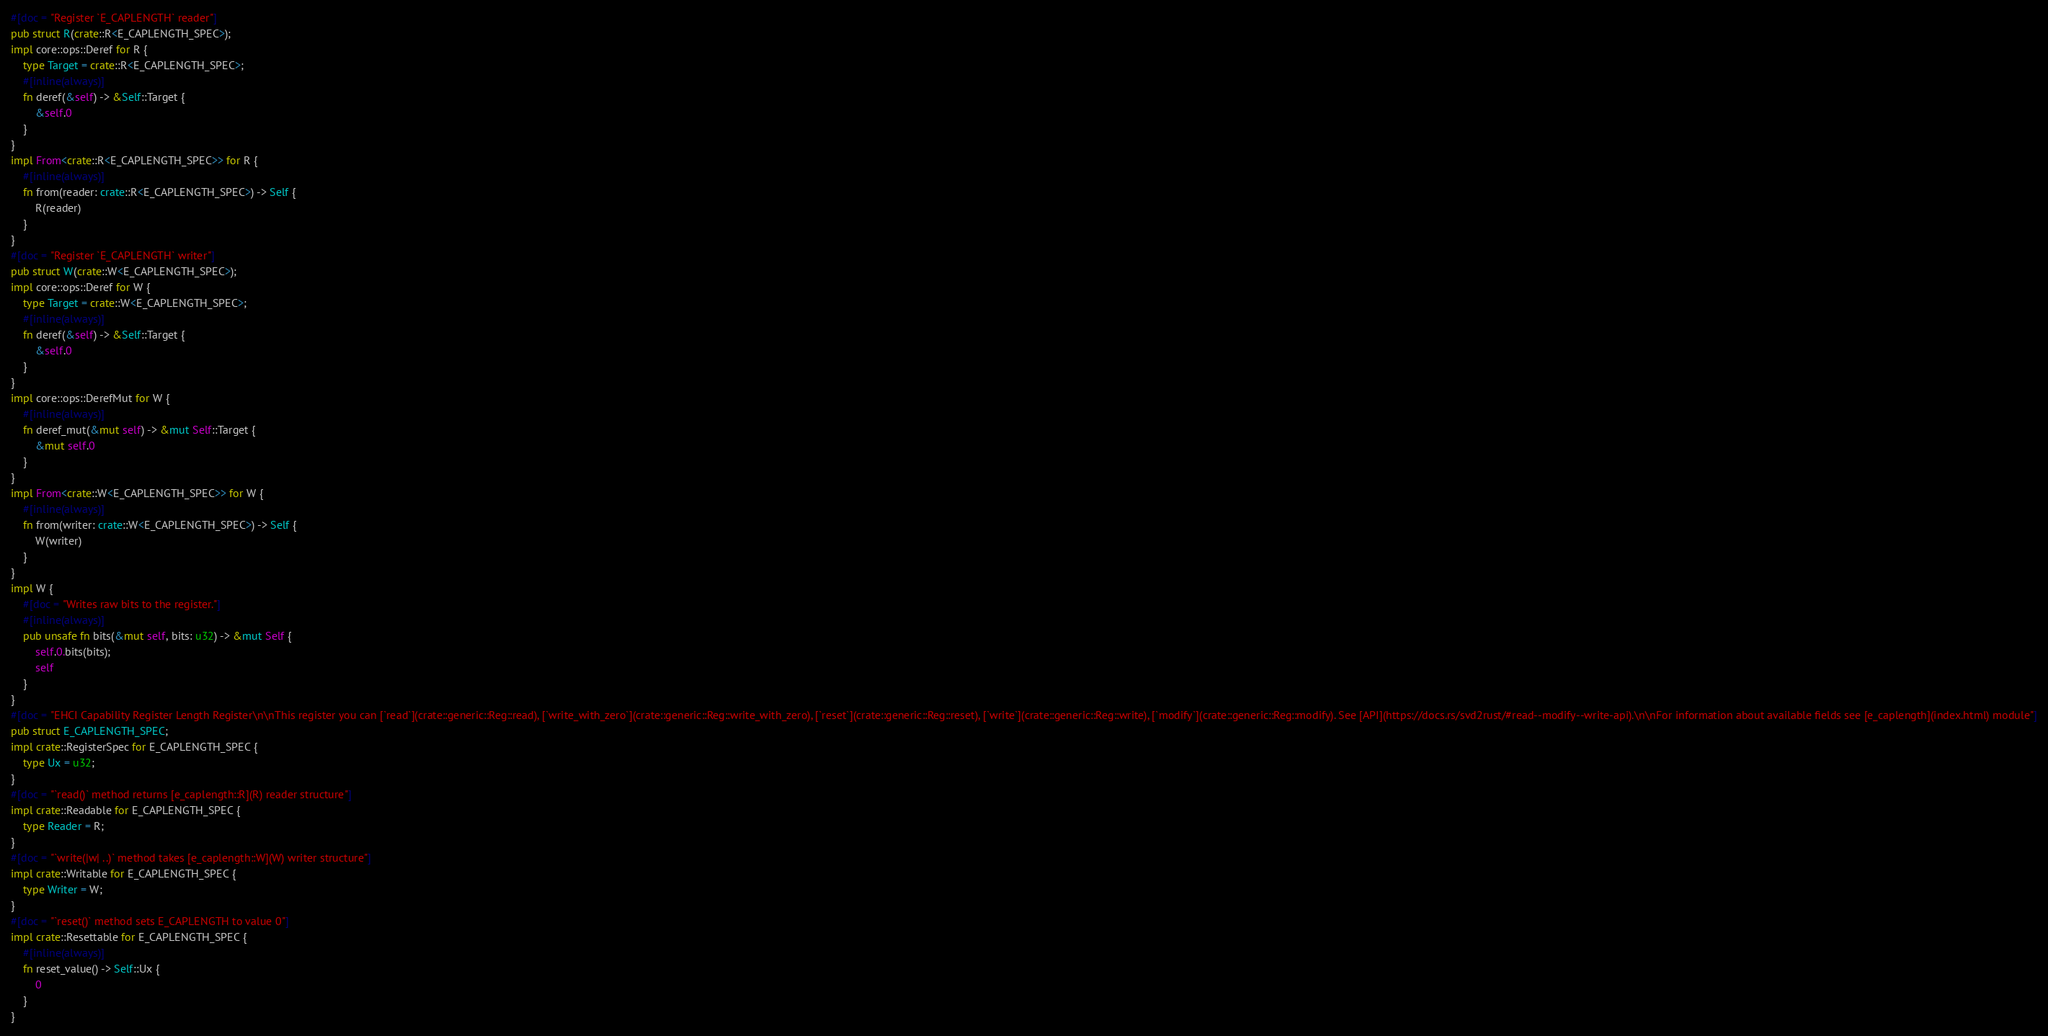<code> <loc_0><loc_0><loc_500><loc_500><_Rust_>#[doc = "Register `E_CAPLENGTH` reader"]
pub struct R(crate::R<E_CAPLENGTH_SPEC>);
impl core::ops::Deref for R {
    type Target = crate::R<E_CAPLENGTH_SPEC>;
    #[inline(always)]
    fn deref(&self) -> &Self::Target {
        &self.0
    }
}
impl From<crate::R<E_CAPLENGTH_SPEC>> for R {
    #[inline(always)]
    fn from(reader: crate::R<E_CAPLENGTH_SPEC>) -> Self {
        R(reader)
    }
}
#[doc = "Register `E_CAPLENGTH` writer"]
pub struct W(crate::W<E_CAPLENGTH_SPEC>);
impl core::ops::Deref for W {
    type Target = crate::W<E_CAPLENGTH_SPEC>;
    #[inline(always)]
    fn deref(&self) -> &Self::Target {
        &self.0
    }
}
impl core::ops::DerefMut for W {
    #[inline(always)]
    fn deref_mut(&mut self) -> &mut Self::Target {
        &mut self.0
    }
}
impl From<crate::W<E_CAPLENGTH_SPEC>> for W {
    #[inline(always)]
    fn from(writer: crate::W<E_CAPLENGTH_SPEC>) -> Self {
        W(writer)
    }
}
impl W {
    #[doc = "Writes raw bits to the register."]
    #[inline(always)]
    pub unsafe fn bits(&mut self, bits: u32) -> &mut Self {
        self.0.bits(bits);
        self
    }
}
#[doc = "EHCI Capability Register Length Register\n\nThis register you can [`read`](crate::generic::Reg::read), [`write_with_zero`](crate::generic::Reg::write_with_zero), [`reset`](crate::generic::Reg::reset), [`write`](crate::generic::Reg::write), [`modify`](crate::generic::Reg::modify). See [API](https://docs.rs/svd2rust/#read--modify--write-api).\n\nFor information about available fields see [e_caplength](index.html) module"]
pub struct E_CAPLENGTH_SPEC;
impl crate::RegisterSpec for E_CAPLENGTH_SPEC {
    type Ux = u32;
}
#[doc = "`read()` method returns [e_caplength::R](R) reader structure"]
impl crate::Readable for E_CAPLENGTH_SPEC {
    type Reader = R;
}
#[doc = "`write(|w| ..)` method takes [e_caplength::W](W) writer structure"]
impl crate::Writable for E_CAPLENGTH_SPEC {
    type Writer = W;
}
#[doc = "`reset()` method sets E_CAPLENGTH to value 0"]
impl crate::Resettable for E_CAPLENGTH_SPEC {
    #[inline(always)]
    fn reset_value() -> Self::Ux {
        0
    }
}
</code> 